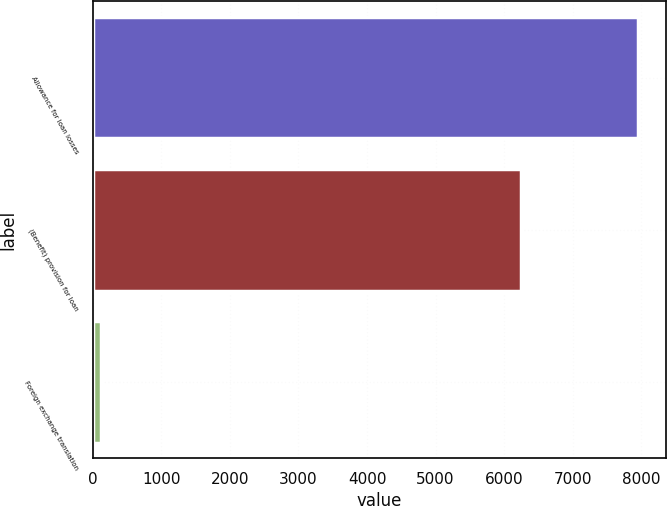<chart> <loc_0><loc_0><loc_500><loc_500><bar_chart><fcel>Allowance for loan losses<fcel>(Benefit) provision for loan<fcel>Foreign exchange translation<nl><fcel>7955<fcel>6242<fcel>117<nl></chart> 